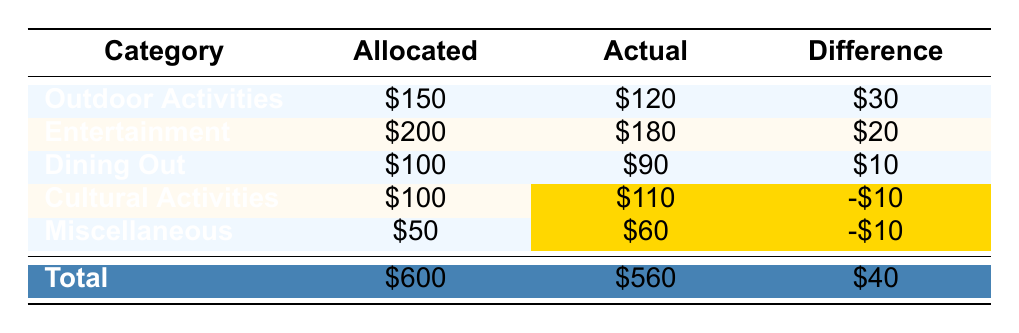What is the total allocated budget for family activities? The total allocated budget is mentioned in the table as \$600.
Answer: 600 How much did the family actually spend on Outdoor Activities? The actual spending on Outdoor Activities is \$120 as shown in the table.
Answer: 120 What is the difference between the allocated amount and the actual amount for Cultural Activities? For Cultural Activities, \$100 was allocated but \$110 was spent, resulting in a difference of -\$10 (indicating an overspend).
Answer: -10 Did the family stay within budget for Dining Out? The allocated amount for Dining Out was \$100, and the actual amount spent was \$90, which means they stayed within budget.
Answer: Yes Which category had the highest over-budget spending? Both Cultural Activities and Miscellaneous categories had overspending of \$10, but they are equal in terms of the amount.
Answer: Cultural Activities and Miscellaneous What is the total amount spent across all categories? The actual amounts spent for each category are added: 120 + 180 + 90 + 110 + 60 = 560.
Answer: 560 Which category spent less than its allocated amount? Outdoor Activities, Entertainment, and Dining Out all spent less than their allocated amounts, with differences of \$30, \$20, and \$10, respectively.
Answer: Outdoor Activities, Entertainment, and Dining Out If the family wants to increase their Dining Out budget by \$20, would they still be within their total budget? The new allocated amount for Dining Out would be \$120, leading to a total budget of \$620, which exceeds the original budget of \$600.
Answer: No How much total did the family spend in categories that exceeded their budget? Since only Cultural Activities and Miscellaneous exceeded their budget, their overspends total \$10 (Cultural Activities) + \$10 (Miscellaneous) = \$20.
Answer: 20 What is the average actual spending across all categories? The total actual spending is \$560 and there are 5 categories, so average spending is 560 / 5 = 112.
Answer: 112 